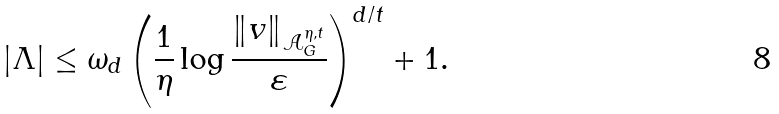Convert formula to latex. <formula><loc_0><loc_0><loc_500><loc_500>| \Lambda | \leq \omega _ { d } \left ( \frac { 1 } { \eta } \log \frac { \| v \| _ { { \mathcal { A } } ^ { \eta , t } _ { G } } } { \varepsilon } \right ) ^ { d / t } + 1 .</formula> 